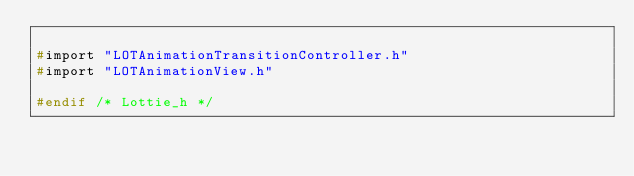<code> <loc_0><loc_0><loc_500><loc_500><_C_>
#import "LOTAnimationTransitionController.h"
#import "LOTAnimationView.h"

#endif /* Lottie_h */
</code> 